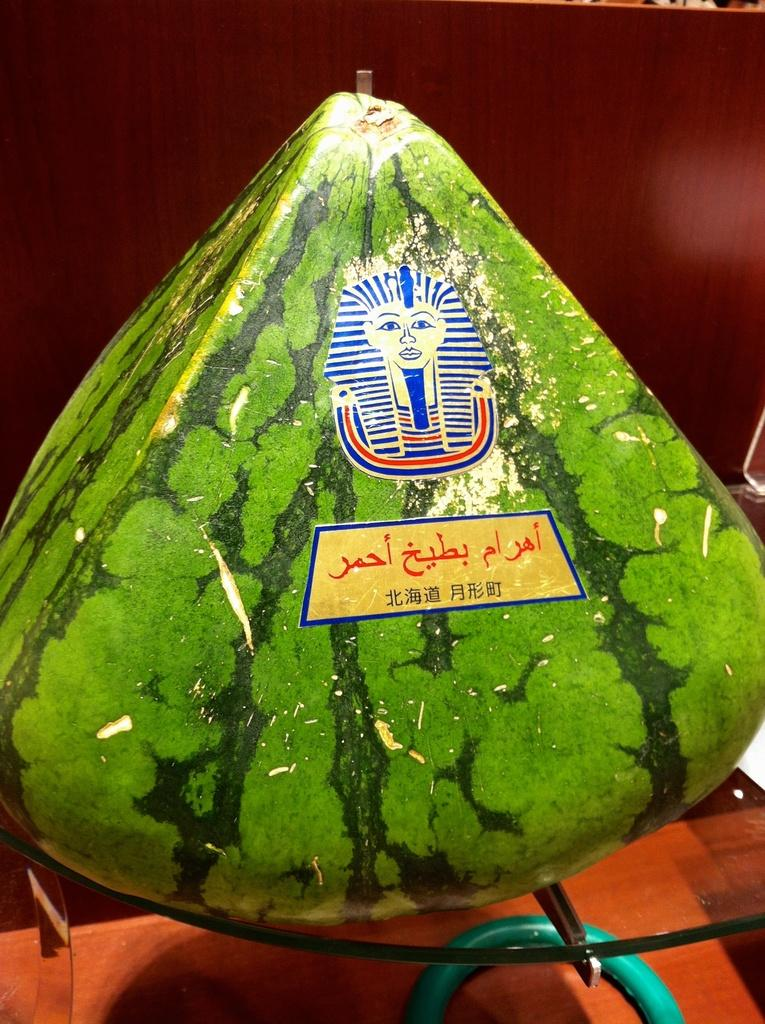What is the main object in the image? There is a watermelon in the image. How is the watermelon positioned? The watermelon is placed on a glass. What is supporting the glass? There is a wooden object under the glass. Can you describe the background of the image? The background of the image is blurred. What type of shoe can be seen in the image? There is no shoe present in the image. Is there any smoke visible in the image? There is no smoke visible in the image. 